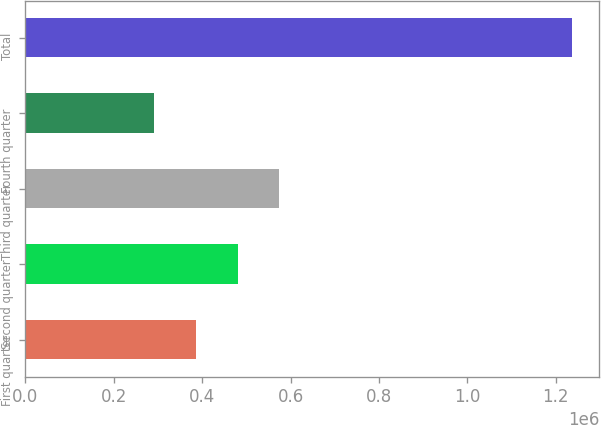<chart> <loc_0><loc_0><loc_500><loc_500><bar_chart><fcel>First quarter<fcel>Second quarter<fcel>Third quarter<fcel>Fourth quarter<fcel>Total<nl><fcel>385680<fcel>480170<fcel>574661<fcel>291190<fcel>1.23609e+06<nl></chart> 